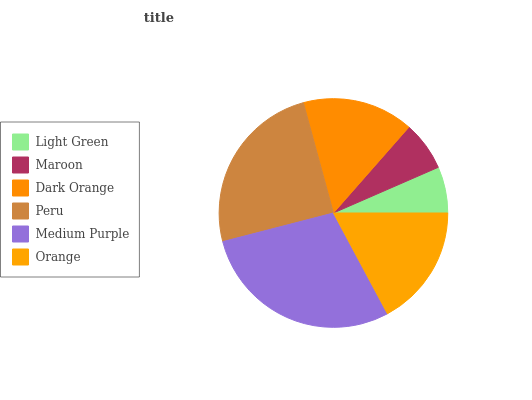Is Light Green the minimum?
Answer yes or no. Yes. Is Medium Purple the maximum?
Answer yes or no. Yes. Is Maroon the minimum?
Answer yes or no. No. Is Maroon the maximum?
Answer yes or no. No. Is Maroon greater than Light Green?
Answer yes or no. Yes. Is Light Green less than Maroon?
Answer yes or no. Yes. Is Light Green greater than Maroon?
Answer yes or no. No. Is Maroon less than Light Green?
Answer yes or no. No. Is Orange the high median?
Answer yes or no. Yes. Is Dark Orange the low median?
Answer yes or no. Yes. Is Light Green the high median?
Answer yes or no. No. Is Orange the low median?
Answer yes or no. No. 